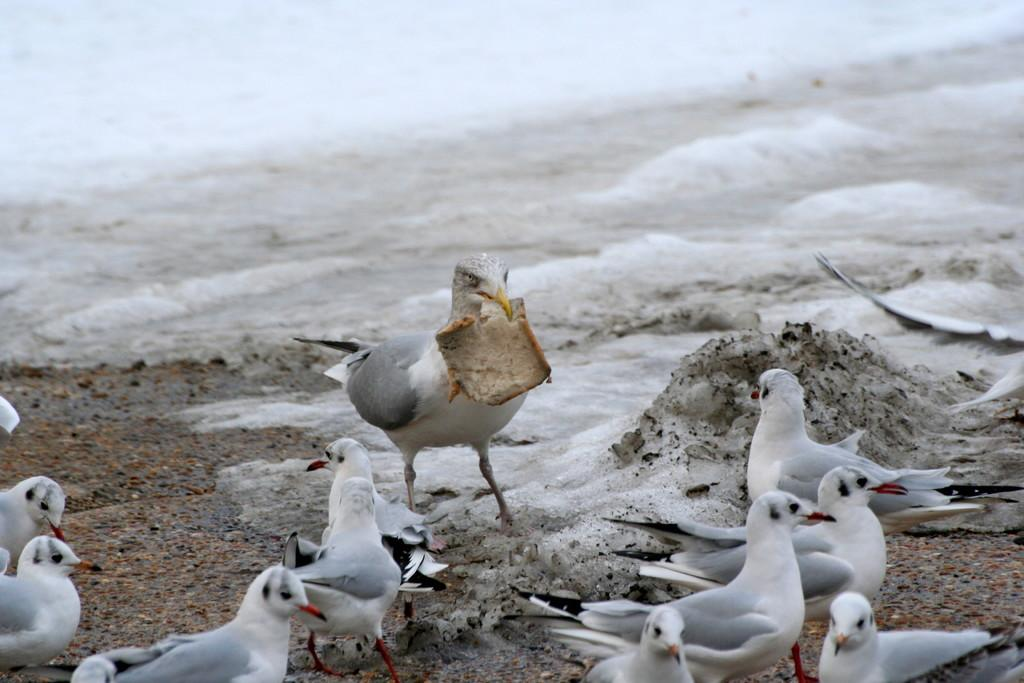What is present on the ground in the image? There are birds on the ground in the image. Can you describe the action of one of the birds in the image? There is a bird holding an object in the image. What can be seen in the water in the image? Waves are visible in the water in the image. What grade did the bird receive for its performance in the image? There is no indication of a performance or grading system in the image, as it features birds on the ground and waves in the water. 